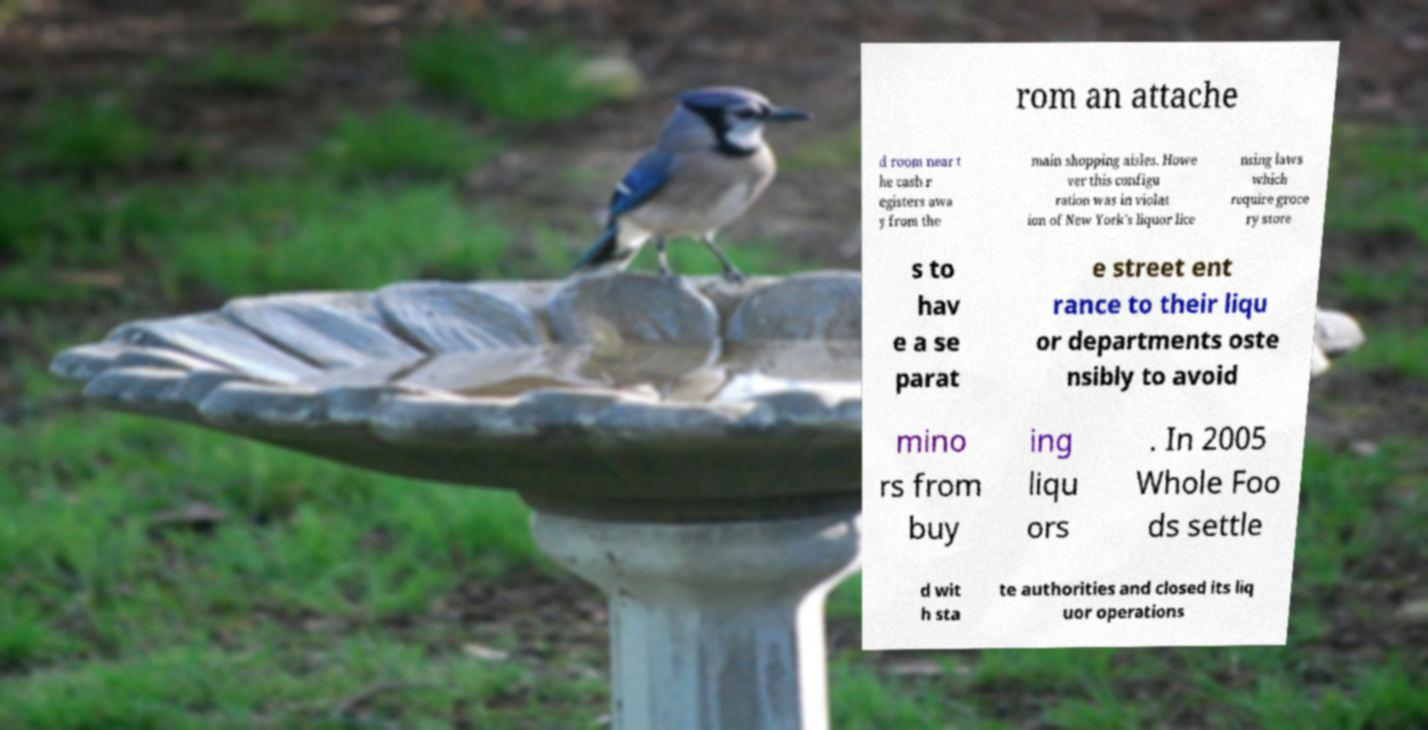I need the written content from this picture converted into text. Can you do that? rom an attache d room near t he cash r egisters awa y from the main shopping aisles. Howe ver this configu ration was in violat ion of New York's liquor lice nsing laws which require groce ry store s to hav e a se parat e street ent rance to their liqu or departments oste nsibly to avoid mino rs from buy ing liqu ors . In 2005 Whole Foo ds settle d wit h sta te authorities and closed its liq uor operations 